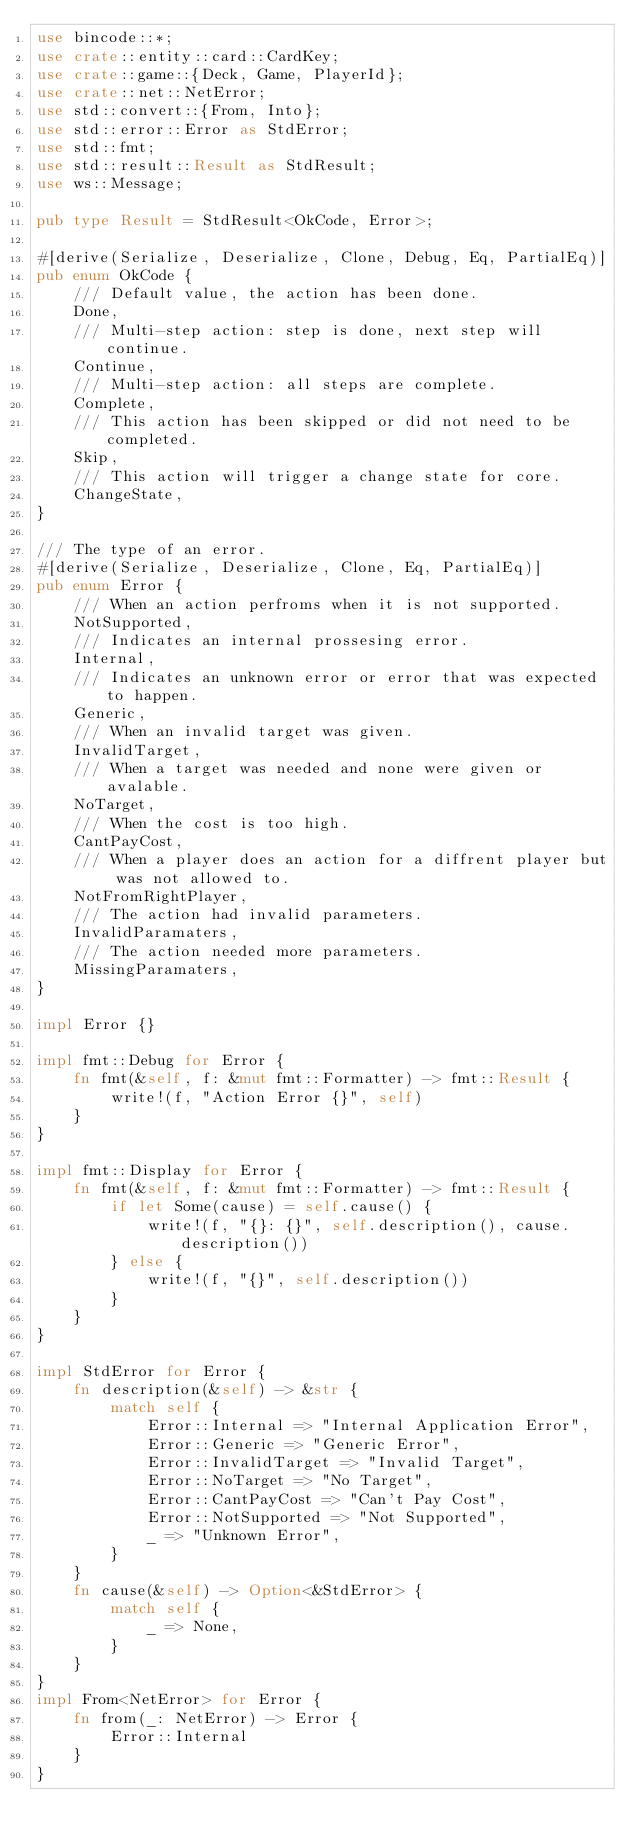Convert code to text. <code><loc_0><loc_0><loc_500><loc_500><_Rust_>use bincode::*;
use crate::entity::card::CardKey;
use crate::game::{Deck, Game, PlayerId};
use crate::net::NetError;
use std::convert::{From, Into};
use std::error::Error as StdError;
use std::fmt;
use std::result::Result as StdResult;
use ws::Message;

pub type Result = StdResult<OkCode, Error>;

#[derive(Serialize, Deserialize, Clone, Debug, Eq, PartialEq)]
pub enum OkCode {
    /// Default value, the action has been done.
    Done,
    /// Multi-step action: step is done, next step will continue.
    Continue,
    /// Multi-step action: all steps are complete.
    Complete,
    /// This action has been skipped or did not need to be completed.
    Skip,
    /// This action will trigger a change state for core.
    ChangeState,
}

/// The type of an error.
#[derive(Serialize, Deserialize, Clone, Eq, PartialEq)]
pub enum Error {
    /// When an action perfroms when it is not supported.
    NotSupported,
    /// Indicates an internal prossesing error.
    Internal,
    /// Indicates an unknown error or error that was expected to happen.
    Generic,
    /// When an invalid target was given.
    InvalidTarget,
    /// When a target was needed and none were given or avalable.
    NoTarget,
    /// When the cost is too high.
    CantPayCost,
    /// When a player does an action for a diffrent player but was not allowed to.
    NotFromRightPlayer,
    /// The action had invalid parameters.
    InvalidParamaters,
    /// The action needed more parameters.
    MissingParamaters,
}

impl Error {}

impl fmt::Debug for Error {
    fn fmt(&self, f: &mut fmt::Formatter) -> fmt::Result {
        write!(f, "Action Error {}", self)
    }
}

impl fmt::Display for Error {
    fn fmt(&self, f: &mut fmt::Formatter) -> fmt::Result {
        if let Some(cause) = self.cause() {
            write!(f, "{}: {}", self.description(), cause.description())
        } else {
            write!(f, "{}", self.description())
        }
    }
}

impl StdError for Error {
    fn description(&self) -> &str {
        match self {
            Error::Internal => "Internal Application Error",
            Error::Generic => "Generic Error",
            Error::InvalidTarget => "Invalid Target",
            Error::NoTarget => "No Target",
            Error::CantPayCost => "Can't Pay Cost",
            Error::NotSupported => "Not Supported",
            _ => "Unknown Error",
        }
    }
    fn cause(&self) -> Option<&StdError> {
        match self {
            _ => None,
        }
    }
}
impl From<NetError> for Error {
    fn from(_: NetError) -> Error {
        Error::Internal
    }
}
</code> 